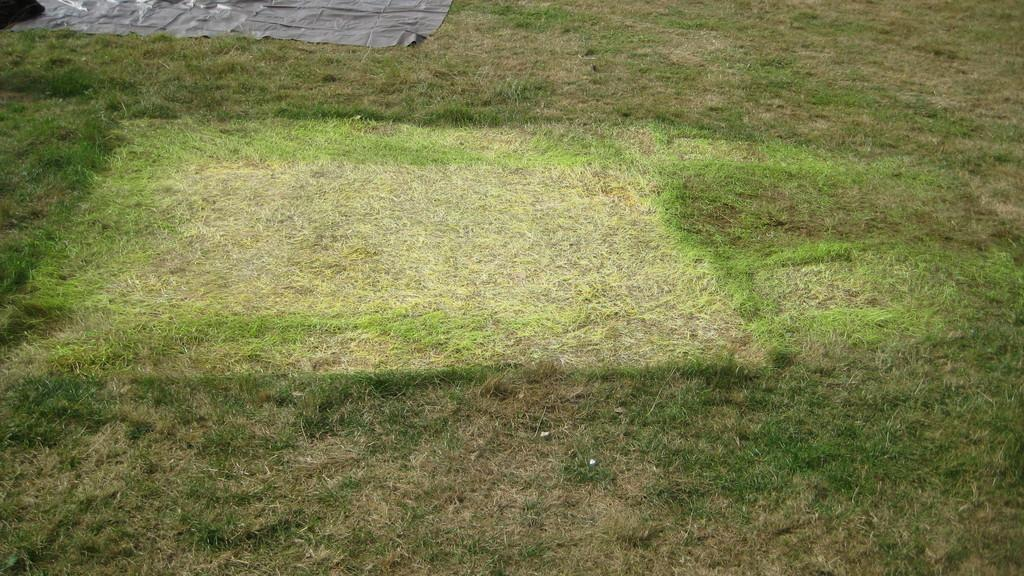What type of terrain is visible in the image? The image contains grassy land. What is covering the top of the image? There is a cover visible at the top of the image. How many roses can be seen growing in the grassy land in the image? There are no roses visible in the image; it only contains grassy land. What type of flight is taking place in the image? There is no flight present in the image; it only contains grassy land and a cover at the top. 